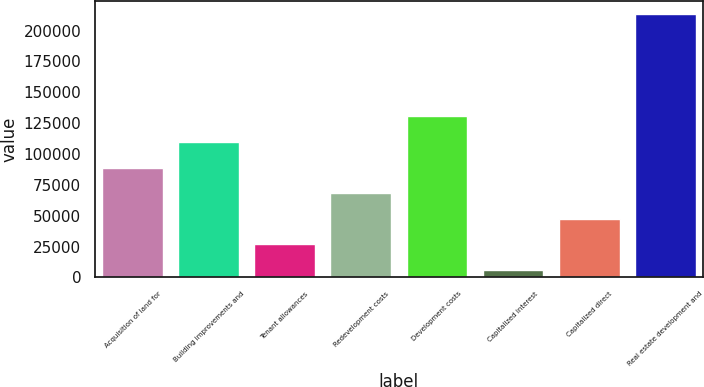<chart> <loc_0><loc_0><loc_500><loc_500><bar_chart><fcel>Acquisition of land for<fcel>Building improvements and<fcel>Tenant allowances<fcel>Redevelopment costs<fcel>Development costs<fcel>Capitalized interest<fcel>Capitalized direct<fcel>Real estate development and<nl><fcel>88959.6<fcel>109680<fcel>26798.4<fcel>68239.2<fcel>130400<fcel>6078<fcel>47518.8<fcel>213282<nl></chart> 